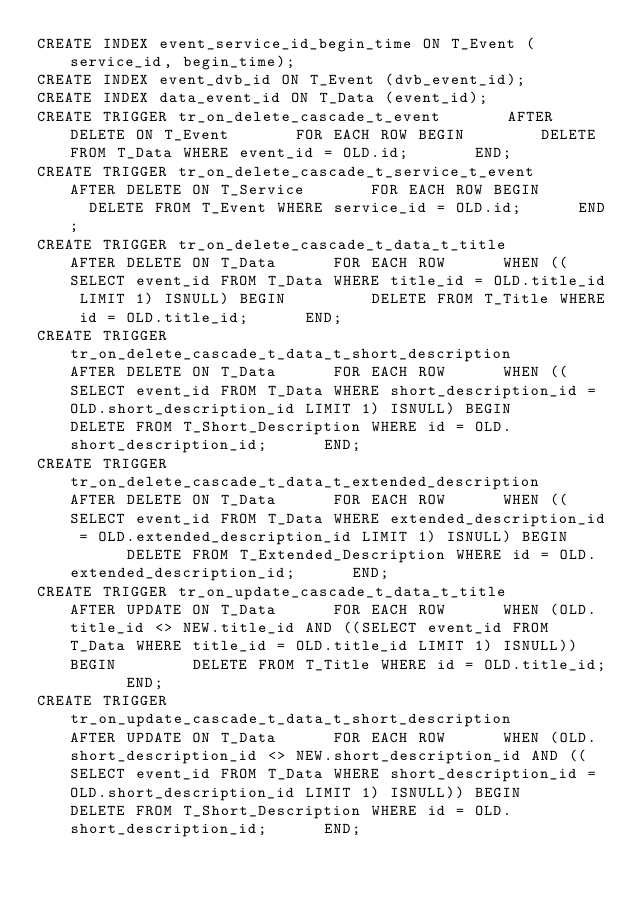<code> <loc_0><loc_0><loc_500><loc_500><_SQL_>CREATE INDEX event_service_id_begin_time ON T_Event (service_id, begin_time);
CREATE INDEX event_dvb_id ON T_Event (dvb_event_id);
CREATE INDEX data_event_id ON T_Data (event_id);
CREATE TRIGGER tr_on_delete_cascade_t_event 			AFTER DELETE ON T_Event 			FOR EACH ROW BEGIN 			  DELETE FROM T_Data WHERE event_id = OLD.id; 			END;
CREATE TRIGGER tr_on_delete_cascade_t_service_t_event 			AFTER DELETE ON T_Service 			FOR EACH ROW BEGIN 			  DELETE FROM T_Event WHERE service_id = OLD.id; 			END;
CREATE TRIGGER tr_on_delete_cascade_t_data_t_title 			AFTER DELETE ON T_Data 			FOR EACH ROW 			WHEN ((SELECT event_id FROM T_Data WHERE title_id = OLD.title_id LIMIT 1) ISNULL) BEGIN 			  DELETE FROM T_Title WHERE id = OLD.title_id; 			END;
CREATE TRIGGER tr_on_delete_cascade_t_data_t_short_description 			AFTER DELETE ON T_Data 			FOR EACH ROW 			WHEN ((SELECT event_id FROM T_Data WHERE short_description_id = OLD.short_description_id LIMIT 1) ISNULL) BEGIN 			  DELETE FROM T_Short_Description WHERE id = OLD.short_description_id; 			END;
CREATE TRIGGER tr_on_delete_cascade_t_data_t_extended_description 			AFTER DELETE ON T_Data 			FOR EACH ROW 			WHEN ((SELECT event_id FROM T_Data WHERE extended_description_id = OLD.extended_description_id LIMIT 1) ISNULL) BEGIN 			  DELETE FROM T_Extended_Description WHERE id = OLD.extended_description_id; 			END;
CREATE TRIGGER tr_on_update_cascade_t_data_t_title 			AFTER UPDATE ON T_Data 			FOR EACH ROW 			WHEN (OLD.title_id <> NEW.title_id AND ((SELECT event_id FROM T_Data WHERE title_id = OLD.title_id LIMIT 1) ISNULL)) BEGIN 			  DELETE FROM T_Title WHERE id = OLD.title_id; 			END;
CREATE TRIGGER tr_on_update_cascade_t_data_t_short_description 			AFTER UPDATE ON T_Data 			FOR EACH ROW 			WHEN (OLD.short_description_id <> NEW.short_description_id AND ((SELECT event_id FROM T_Data WHERE short_description_id = OLD.short_description_id LIMIT 1) ISNULL)) BEGIN 			  DELETE FROM T_Short_Description WHERE id = OLD.short_description_id; 			END;</code> 